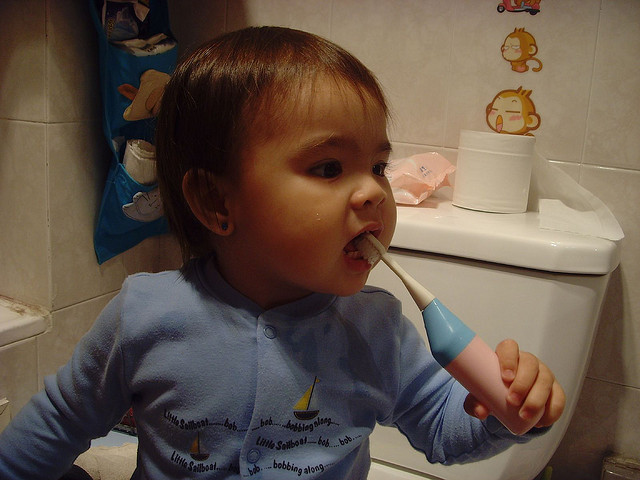Read all the text in this image. bob Little Sailboat bed bob along bob bobbing 